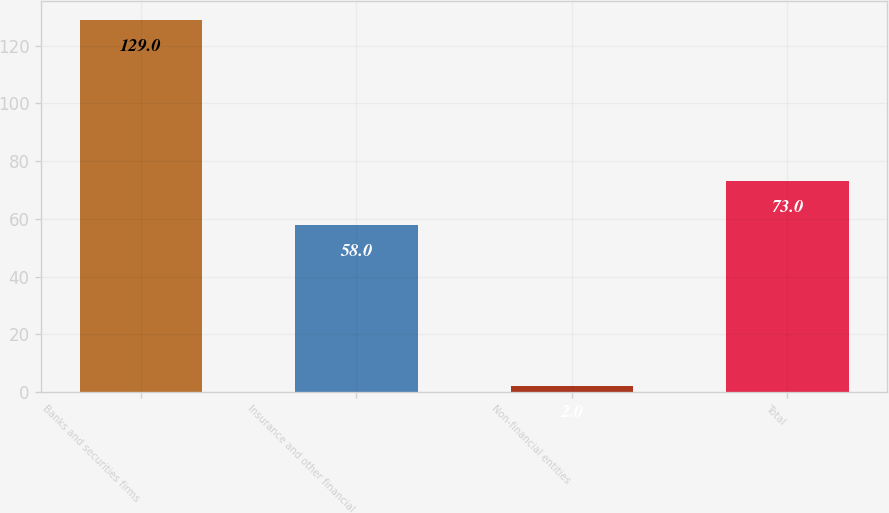<chart> <loc_0><loc_0><loc_500><loc_500><bar_chart><fcel>Banks and securities firms<fcel>Insurance and other financial<fcel>Non-financial entities<fcel>Total<nl><fcel>129<fcel>58<fcel>2<fcel>73<nl></chart> 